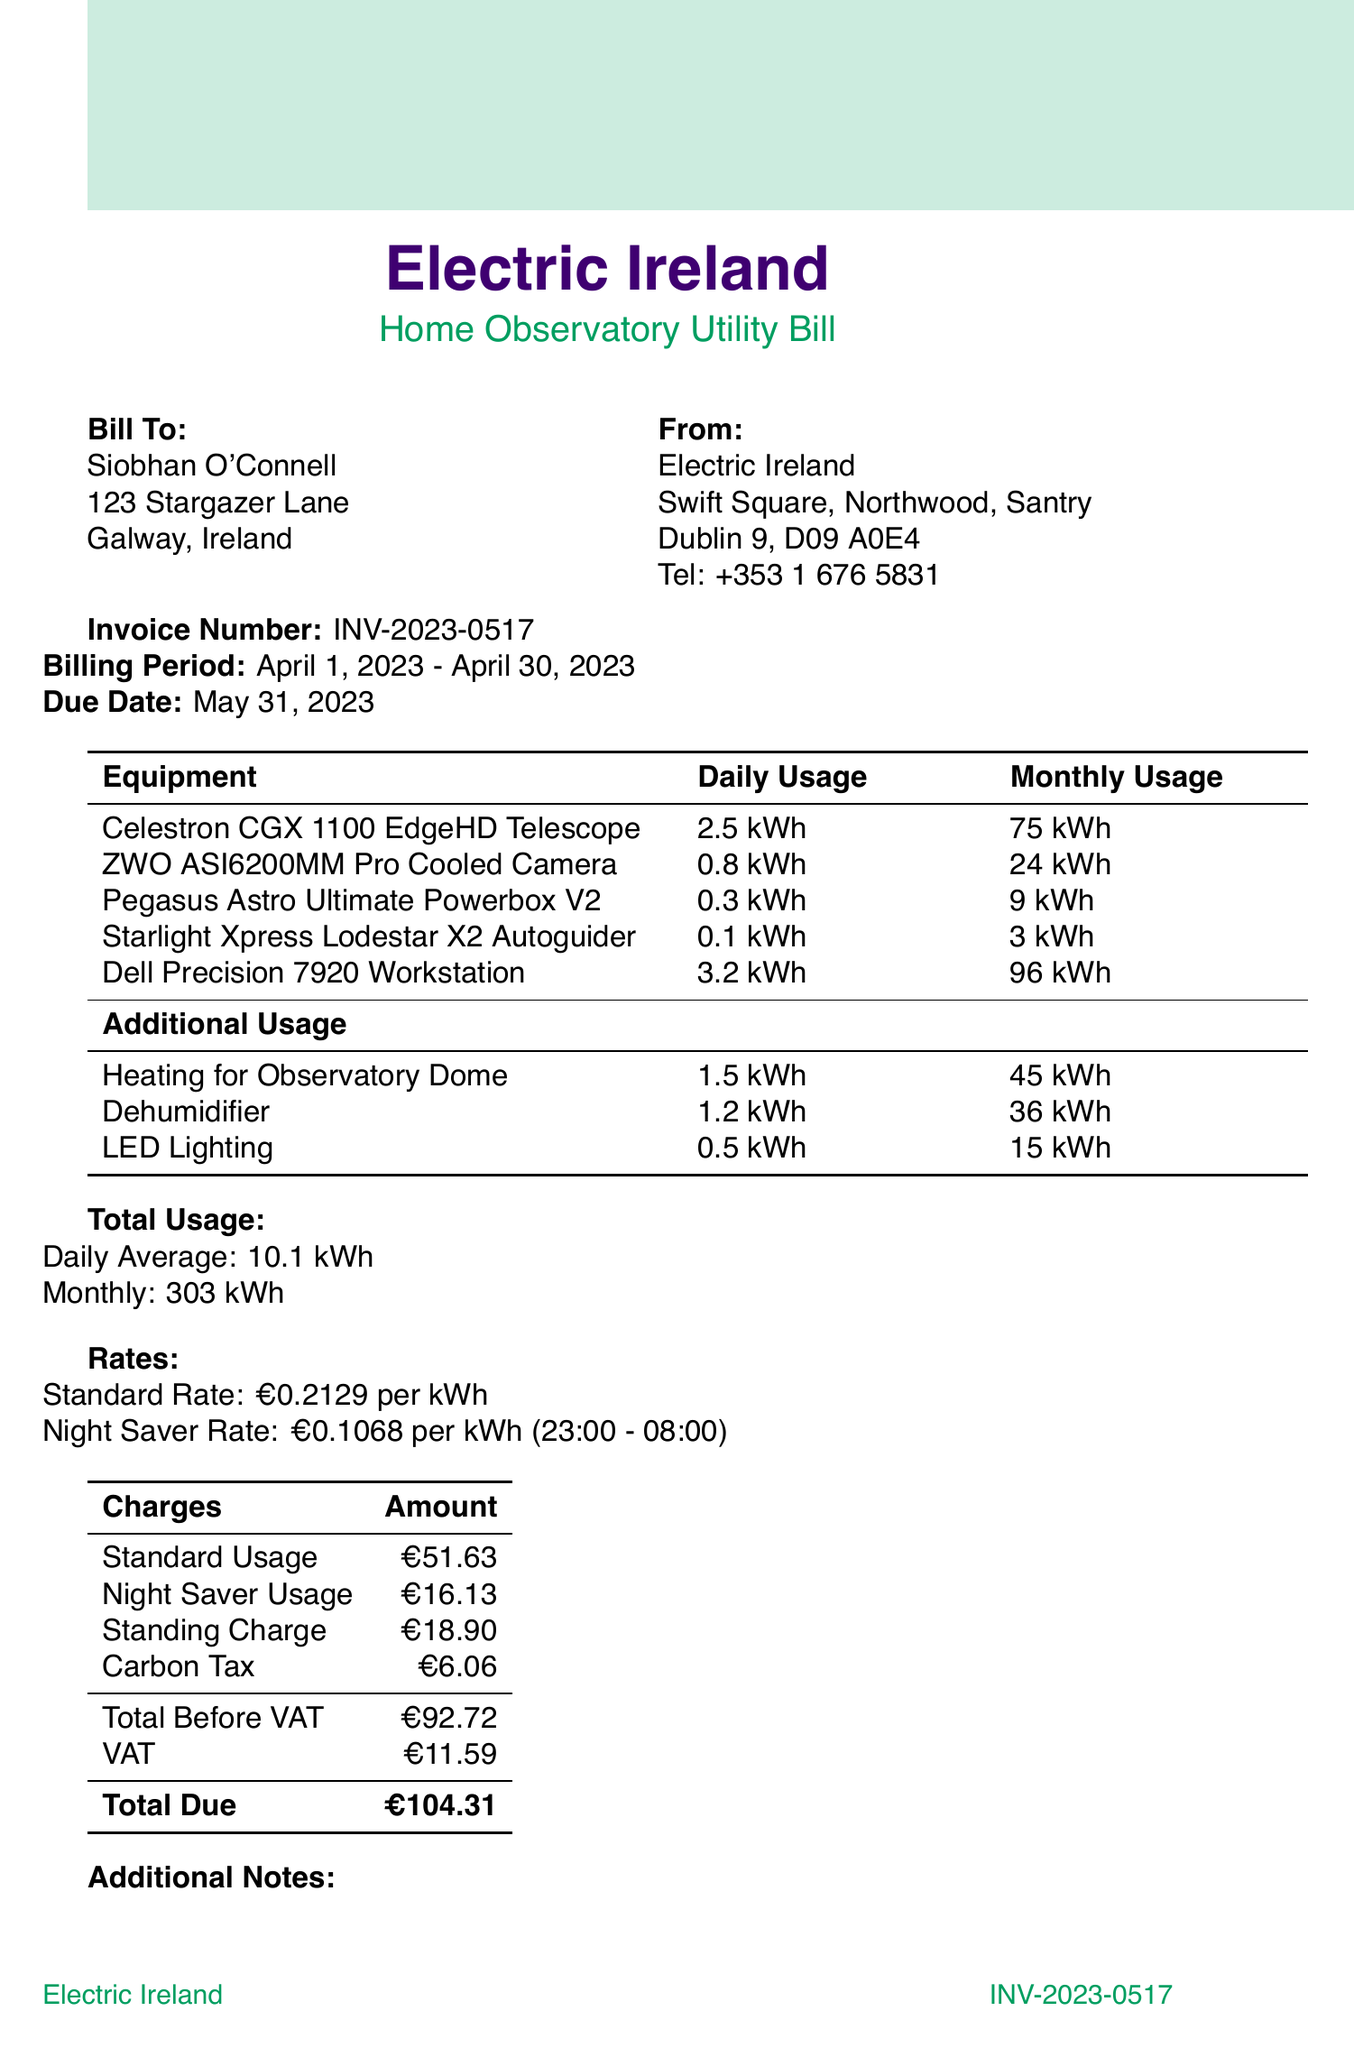What is the invoice number? The invoice number is listed at the top of the document, identifying the specific billing instance.
Answer: INV-2023-0517 Who is the service provider? The service provider is identified in the document with their official name and address.
Answer: Electric Ireland What is the total due amount? The total due amount is calculated by adding all the charges, including VAT.
Answer: €104.31 What period does this invoice cover? The billing period indicates the duration for which the utility service was billed.
Answer: April 1, 2023 - April 30, 2023 How much is the carbon tax? The carbon tax is specifically listed as one of the charges in the invoice.
Answer: €6.06 What is the daily average usage? The daily average usage summarizes the total consumption calculated for daily monitoring.
Answer: 10.1 kWh What discount was applied? The discount applied is mentioned as part of a specific initiative for women in science.
Answer: 5% What payment options are available? The document outlines various methods available for settling the invoice payment.
Answer: Online banking transfer, Direct debit, Credit card payment via our website, Cheque by post What is the monthly usage for the Dell Precision 7920 Workstation? The monthly usage provides specific electrical consumption details for this piece of equipment.
Answer: 96 kWh 